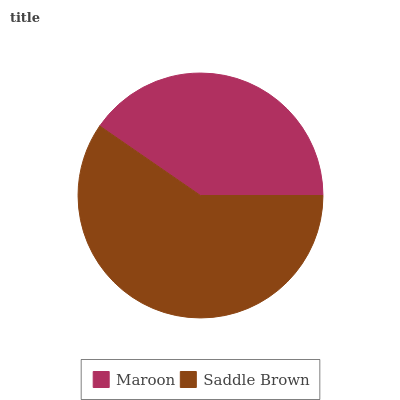Is Maroon the minimum?
Answer yes or no. Yes. Is Saddle Brown the maximum?
Answer yes or no. Yes. Is Saddle Brown the minimum?
Answer yes or no. No. Is Saddle Brown greater than Maroon?
Answer yes or no. Yes. Is Maroon less than Saddle Brown?
Answer yes or no. Yes. Is Maroon greater than Saddle Brown?
Answer yes or no. No. Is Saddle Brown less than Maroon?
Answer yes or no. No. Is Saddle Brown the high median?
Answer yes or no. Yes. Is Maroon the low median?
Answer yes or no. Yes. Is Maroon the high median?
Answer yes or no. No. Is Saddle Brown the low median?
Answer yes or no. No. 